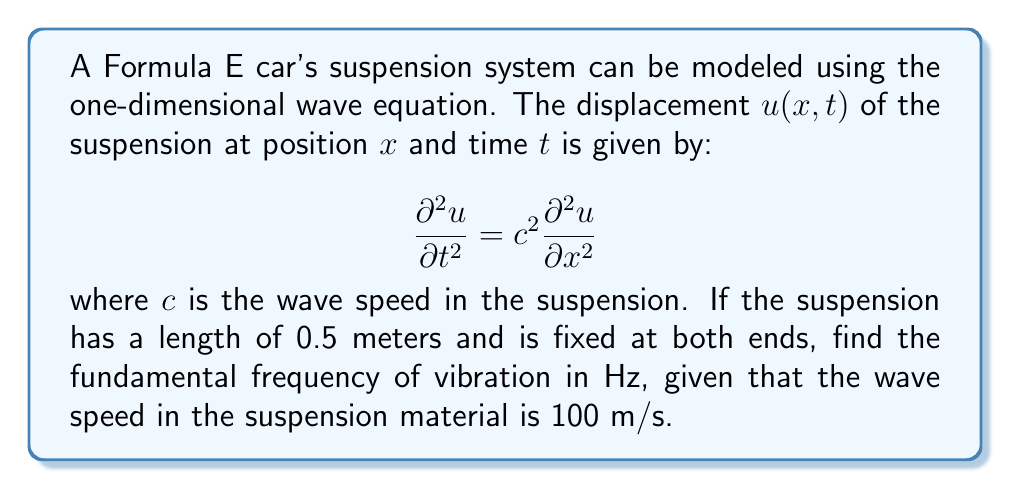Show me your answer to this math problem. To solve this problem, we'll follow these steps:

1) For a string (or in this case, a suspension) fixed at both ends, the general solution for the wave equation is:

   $$u(x,t) = \sum_{n=1}^{\infty} A_n \sin(\frac{n\pi x}{L}) \cos(\frac{n\pi c t}{L})$$

   where $L$ is the length of the suspension.

2) The fundamental frequency corresponds to $n=1$ in this solution.

3) The angular frequency $\omega$ for the fundamental mode is:

   $$\omega = \frac{\pi c}{L}$$

4) We can convert this to frequency $f$ in Hz using:

   $$f = \frac{\omega}{2\pi} = \frac{c}{2L}$$

5) Now, let's plug in our values:
   $c = 100$ m/s
   $L = 0.5$ m

   $$f = \frac{100}{2(0.5)} = \frac{100}{1} = 100$$

Therefore, the fundamental frequency is 100 Hz.
Answer: 100 Hz 